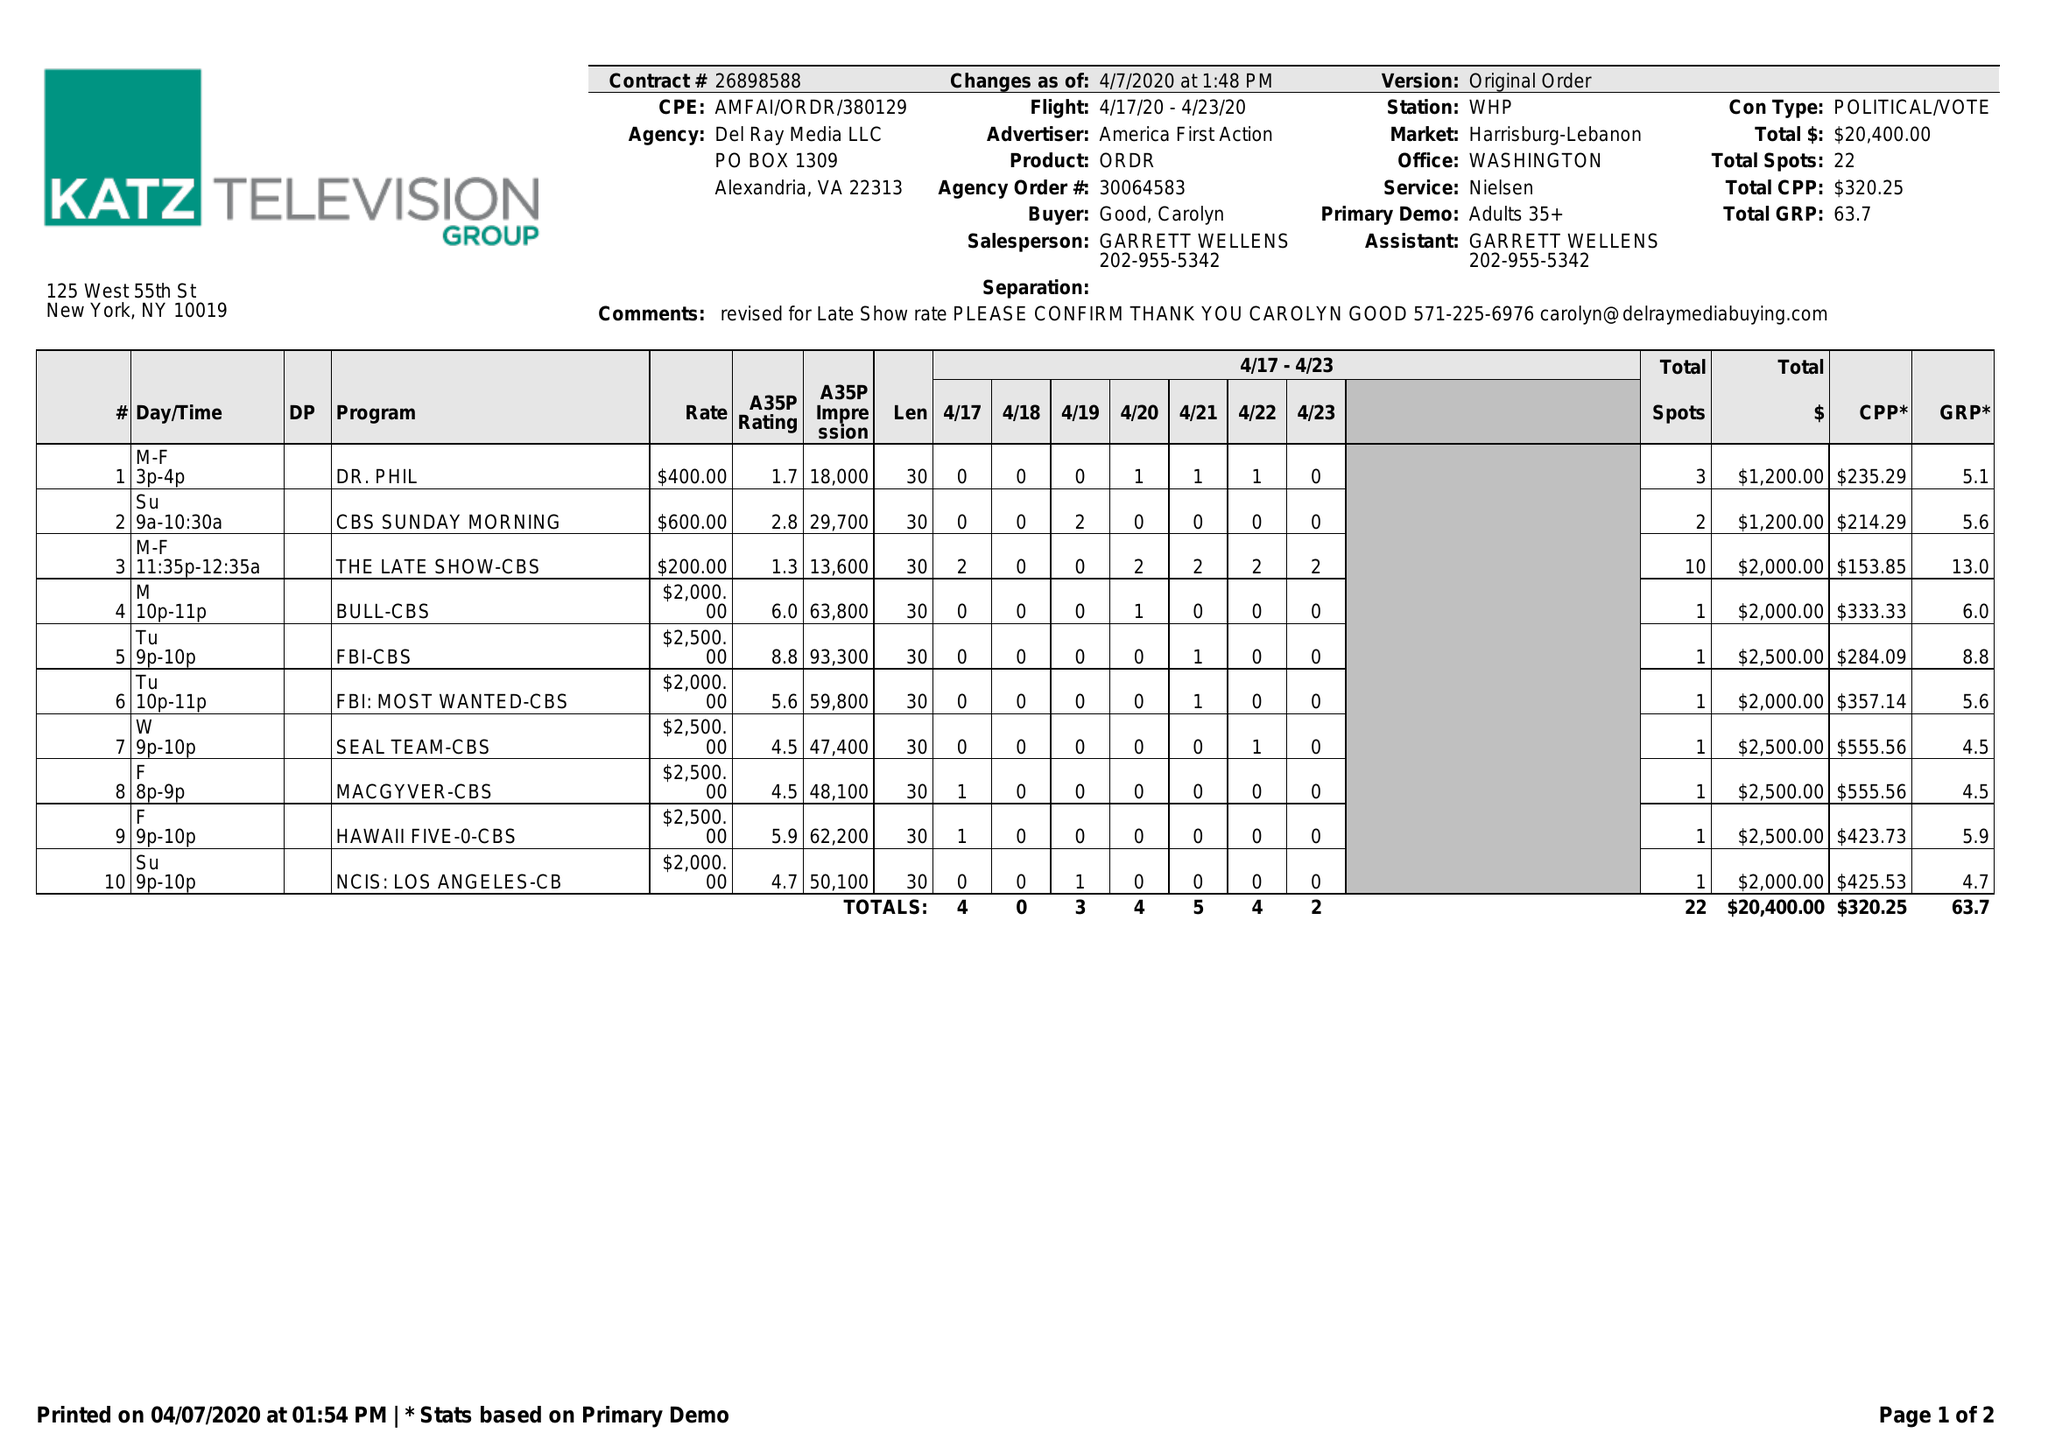What is the value for the flight_to?
Answer the question using a single word or phrase. 04/23/20 